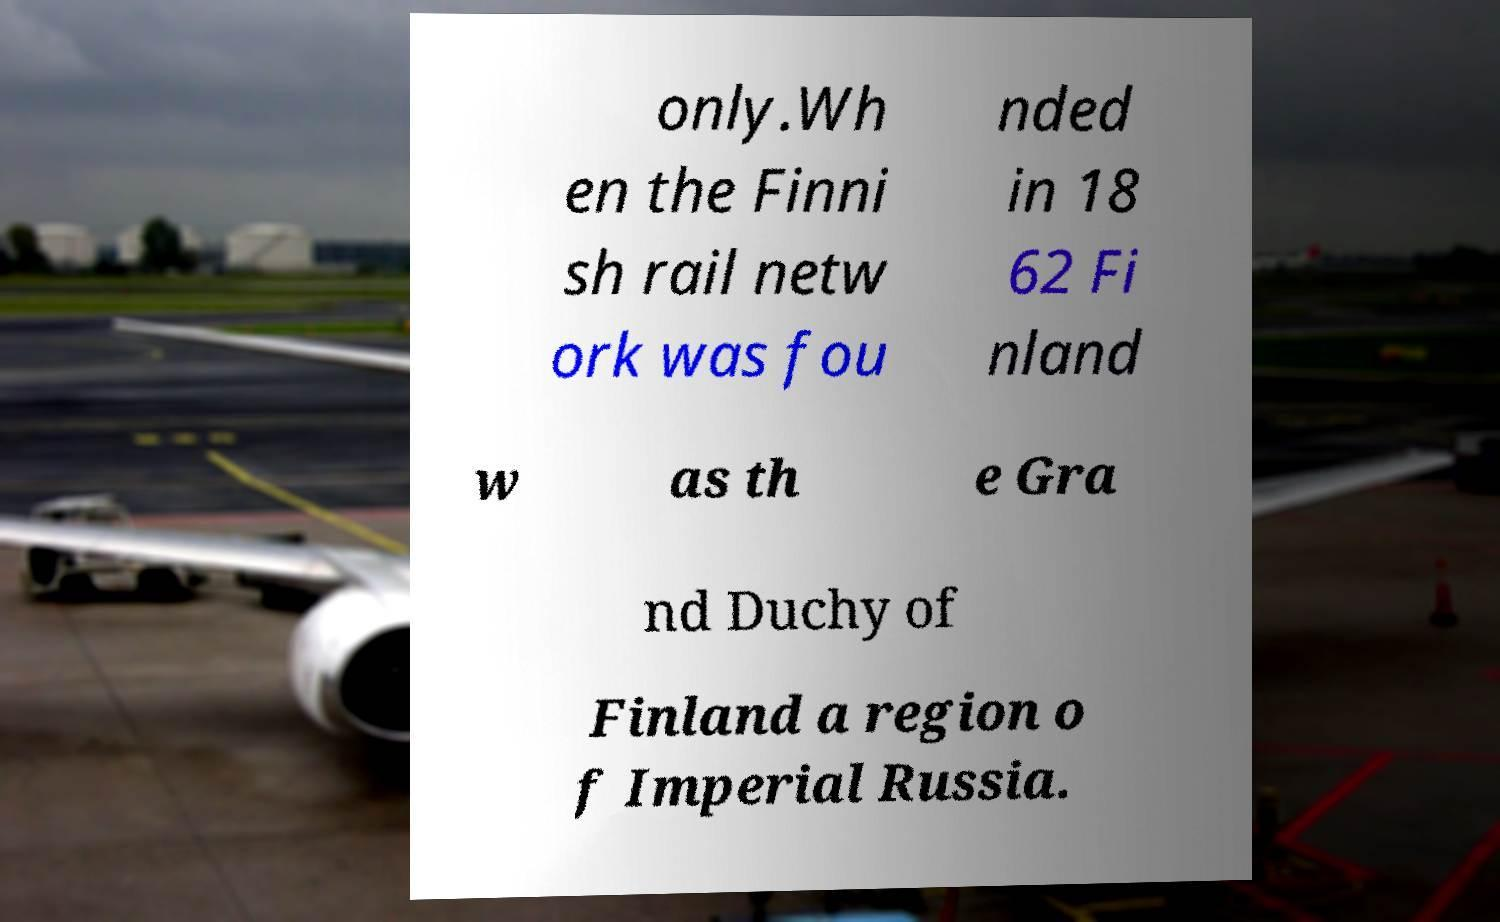Could you assist in decoding the text presented in this image and type it out clearly? only.Wh en the Finni sh rail netw ork was fou nded in 18 62 Fi nland w as th e Gra nd Duchy of Finland a region o f Imperial Russia. 